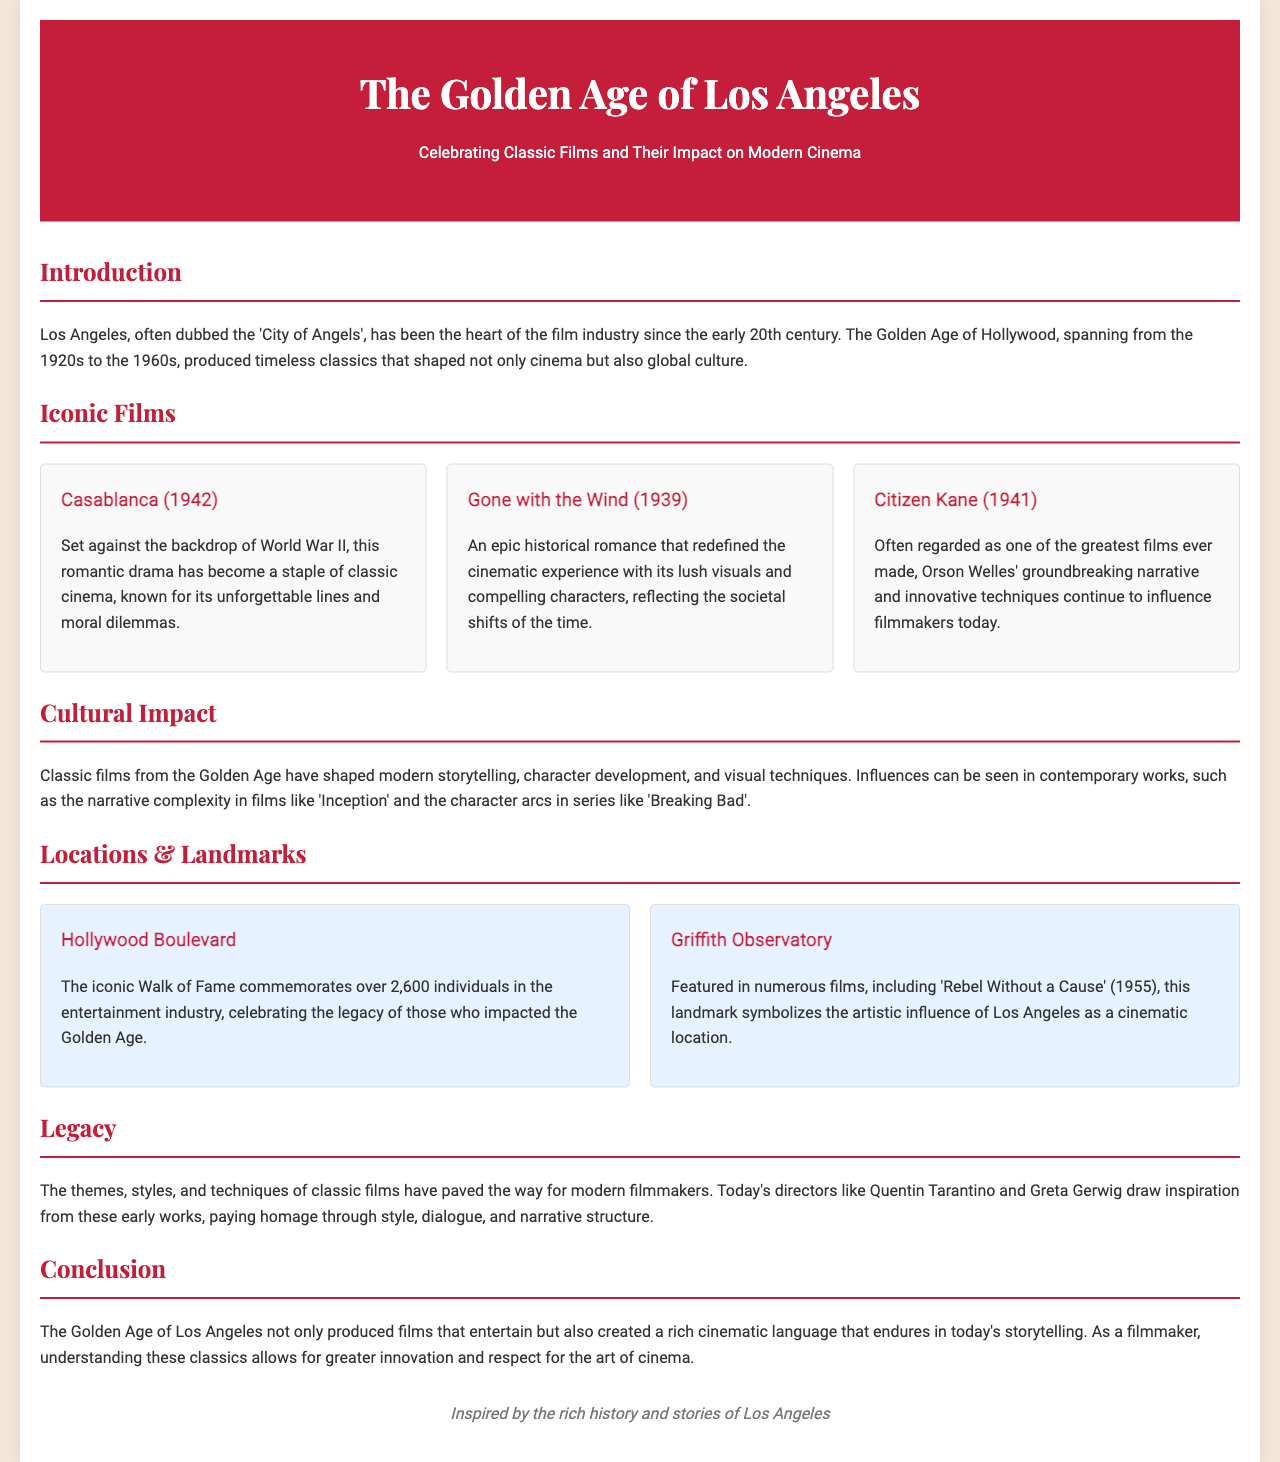What is the title of the brochure? The title is prominently displayed at the top of the document.
Answer: The Golden Age of Los Angeles: Celebrating Classic Films and Their Impact on Modern Cinema What year was "Casablanca" released? The release year is mentioned alongside the film title in the document.
Answer: 1942 Which landmark is featured in 'Rebel Without a Cause'? The document lists landmarks and mentions this film in relation to one of them.
Answer: Griffith Observatory What are the two films mentioned in the Iconic Films section besides "Citizen Kane"? The document provides a list of iconic films in a specific section.
Answer: Casablanca, Gone with the Wind Which filmmaker is known for drawing inspiration from classic films according to the Legacy section? The document mentions current filmmakers who draw inspiration from classic films.
Answer: Quentin Tarantino How many individuals are commemorated on the Hollywood Walk of Fame? The document states that the Hollywood Boulevard commemorates a specific number of individuals.
Answer: Over 2,600 What does the Cultural Impact section highlight about modern storytelling? The Cultural Impact section discusses influences on storytelling techniques in modern works.
Answer: Narrative complexity What is the main theme of the Introduction section? The Introduction section outlines the historical significance of Los Angeles in film.
Answer: The Golden Age of Hollywood What is the background color of the brochure? The style section provides a description of the background color used in the document.
Answer: #f4e8d9 